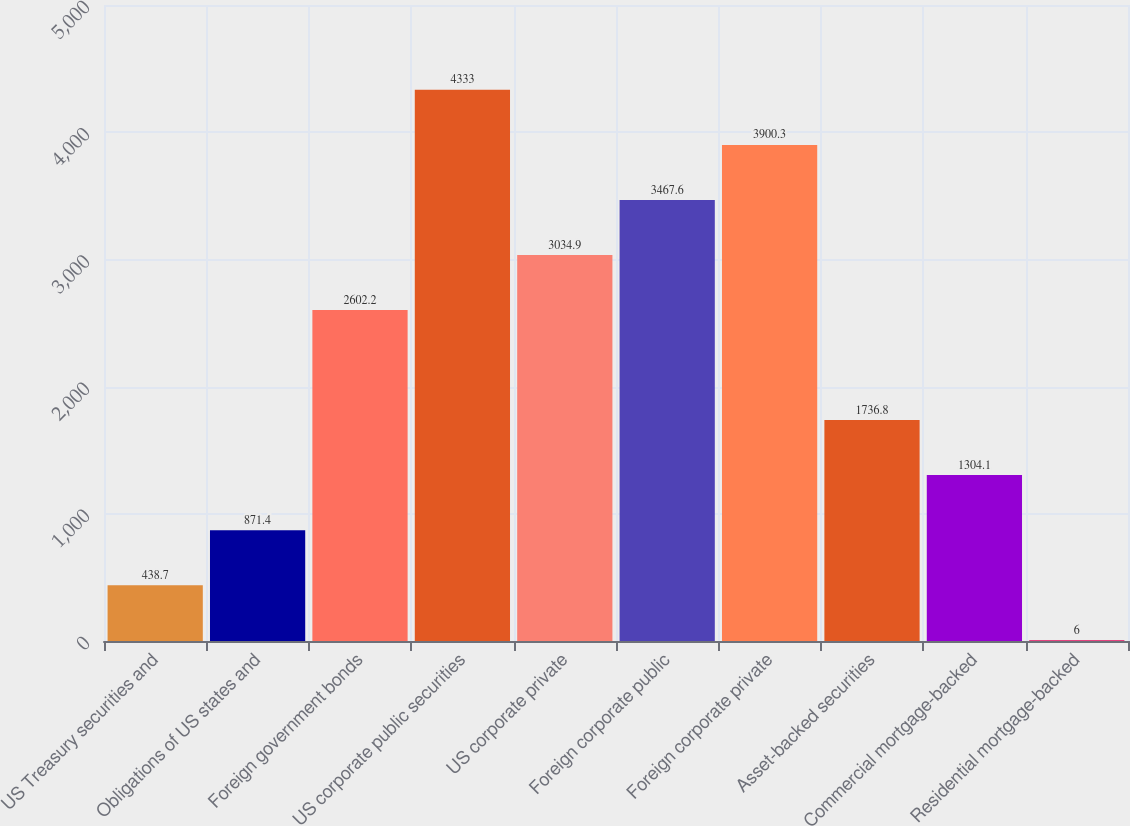Convert chart. <chart><loc_0><loc_0><loc_500><loc_500><bar_chart><fcel>US Treasury securities and<fcel>Obligations of US states and<fcel>Foreign government bonds<fcel>US corporate public securities<fcel>US corporate private<fcel>Foreign corporate public<fcel>Foreign corporate private<fcel>Asset-backed securities<fcel>Commercial mortgage-backed<fcel>Residential mortgage-backed<nl><fcel>438.7<fcel>871.4<fcel>2602.2<fcel>4333<fcel>3034.9<fcel>3467.6<fcel>3900.3<fcel>1736.8<fcel>1304.1<fcel>6<nl></chart> 